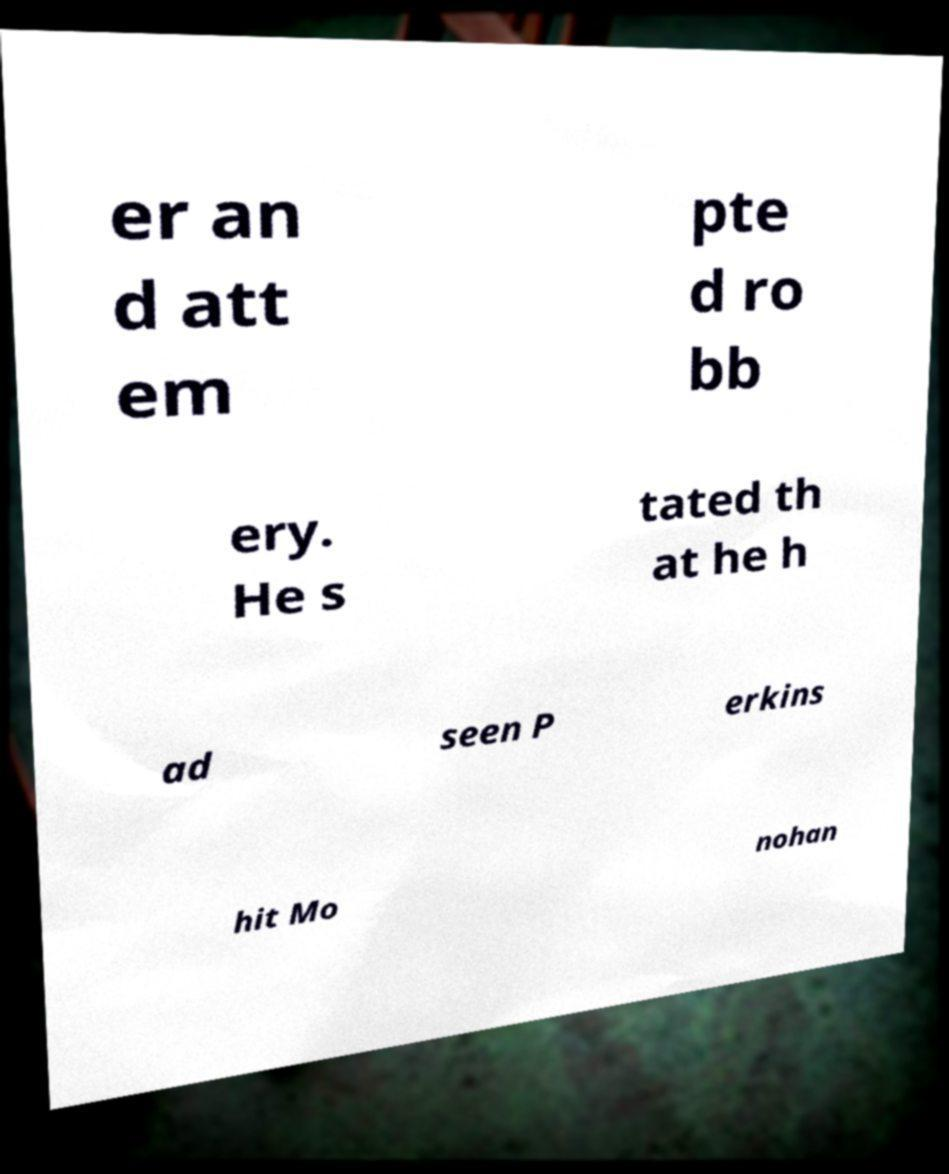Can you read and provide the text displayed in the image?This photo seems to have some interesting text. Can you extract and type it out for me? er an d att em pte d ro bb ery. He s tated th at he h ad seen P erkins hit Mo nohan 